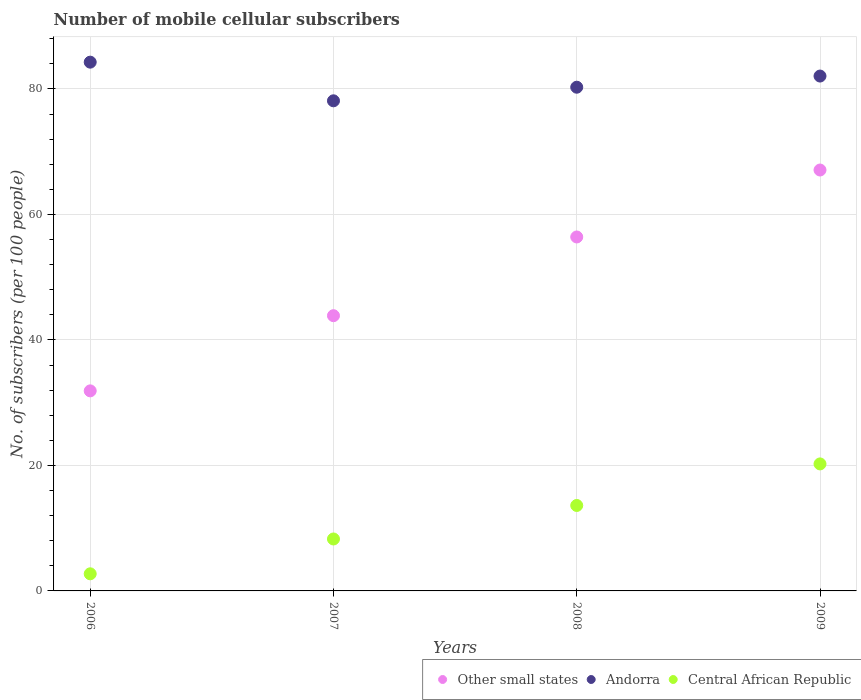How many different coloured dotlines are there?
Make the answer very short. 3. Is the number of dotlines equal to the number of legend labels?
Provide a short and direct response. Yes. What is the number of mobile cellular subscribers in Andorra in 2009?
Provide a short and direct response. 82.06. Across all years, what is the maximum number of mobile cellular subscribers in Central African Republic?
Give a very brief answer. 20.24. Across all years, what is the minimum number of mobile cellular subscribers in Other small states?
Give a very brief answer. 31.89. In which year was the number of mobile cellular subscribers in Central African Republic maximum?
Your answer should be compact. 2009. In which year was the number of mobile cellular subscribers in Andorra minimum?
Your answer should be compact. 2007. What is the total number of mobile cellular subscribers in Central African Republic in the graph?
Your answer should be compact. 44.87. What is the difference between the number of mobile cellular subscribers in Central African Republic in 2006 and that in 2008?
Your response must be concise. -10.89. What is the difference between the number of mobile cellular subscribers in Other small states in 2008 and the number of mobile cellular subscribers in Central African Republic in 2009?
Your response must be concise. 36.17. What is the average number of mobile cellular subscribers in Other small states per year?
Your answer should be compact. 49.81. In the year 2007, what is the difference between the number of mobile cellular subscribers in Andorra and number of mobile cellular subscribers in Other small states?
Provide a short and direct response. 34.25. What is the ratio of the number of mobile cellular subscribers in Central African Republic in 2006 to that in 2009?
Give a very brief answer. 0.13. Is the number of mobile cellular subscribers in Other small states in 2006 less than that in 2007?
Provide a succinct answer. Yes. What is the difference between the highest and the second highest number of mobile cellular subscribers in Central African Republic?
Keep it short and to the point. 6.62. What is the difference between the highest and the lowest number of mobile cellular subscribers in Andorra?
Provide a short and direct response. 6.16. In how many years, is the number of mobile cellular subscribers in Central African Republic greater than the average number of mobile cellular subscribers in Central African Republic taken over all years?
Provide a succinct answer. 2. Is it the case that in every year, the sum of the number of mobile cellular subscribers in Andorra and number of mobile cellular subscribers in Other small states  is greater than the number of mobile cellular subscribers in Central African Republic?
Give a very brief answer. Yes. How many dotlines are there?
Keep it short and to the point. 3. How many years are there in the graph?
Keep it short and to the point. 4. Are the values on the major ticks of Y-axis written in scientific E-notation?
Offer a terse response. No. Does the graph contain any zero values?
Ensure brevity in your answer.  No. Does the graph contain grids?
Keep it short and to the point. Yes. Where does the legend appear in the graph?
Make the answer very short. Bottom right. How many legend labels are there?
Make the answer very short. 3. How are the legend labels stacked?
Your response must be concise. Horizontal. What is the title of the graph?
Make the answer very short. Number of mobile cellular subscribers. What is the label or title of the Y-axis?
Provide a short and direct response. No. of subscribers (per 100 people). What is the No. of subscribers (per 100 people) in Other small states in 2006?
Ensure brevity in your answer.  31.89. What is the No. of subscribers (per 100 people) in Andorra in 2006?
Your response must be concise. 84.28. What is the No. of subscribers (per 100 people) in Central African Republic in 2006?
Ensure brevity in your answer.  2.73. What is the No. of subscribers (per 100 people) in Other small states in 2007?
Your answer should be very brief. 43.87. What is the No. of subscribers (per 100 people) in Andorra in 2007?
Offer a very short reply. 78.12. What is the No. of subscribers (per 100 people) in Central African Republic in 2007?
Provide a succinct answer. 8.28. What is the No. of subscribers (per 100 people) of Other small states in 2008?
Ensure brevity in your answer.  56.41. What is the No. of subscribers (per 100 people) in Andorra in 2008?
Provide a succinct answer. 80.28. What is the No. of subscribers (per 100 people) of Central African Republic in 2008?
Your response must be concise. 13.62. What is the No. of subscribers (per 100 people) in Other small states in 2009?
Ensure brevity in your answer.  67.09. What is the No. of subscribers (per 100 people) in Andorra in 2009?
Provide a succinct answer. 82.06. What is the No. of subscribers (per 100 people) of Central African Republic in 2009?
Your response must be concise. 20.24. Across all years, what is the maximum No. of subscribers (per 100 people) in Other small states?
Make the answer very short. 67.09. Across all years, what is the maximum No. of subscribers (per 100 people) of Andorra?
Provide a short and direct response. 84.28. Across all years, what is the maximum No. of subscribers (per 100 people) of Central African Republic?
Your answer should be very brief. 20.24. Across all years, what is the minimum No. of subscribers (per 100 people) in Other small states?
Offer a terse response. 31.89. Across all years, what is the minimum No. of subscribers (per 100 people) of Andorra?
Make the answer very short. 78.12. Across all years, what is the minimum No. of subscribers (per 100 people) of Central African Republic?
Provide a succinct answer. 2.73. What is the total No. of subscribers (per 100 people) of Other small states in the graph?
Make the answer very short. 199.26. What is the total No. of subscribers (per 100 people) in Andorra in the graph?
Offer a very short reply. 324.74. What is the total No. of subscribers (per 100 people) of Central African Republic in the graph?
Give a very brief answer. 44.87. What is the difference between the No. of subscribers (per 100 people) in Other small states in 2006 and that in 2007?
Provide a short and direct response. -11.98. What is the difference between the No. of subscribers (per 100 people) in Andorra in 2006 and that in 2007?
Your answer should be compact. 6.16. What is the difference between the No. of subscribers (per 100 people) in Central African Republic in 2006 and that in 2007?
Provide a succinct answer. -5.55. What is the difference between the No. of subscribers (per 100 people) in Other small states in 2006 and that in 2008?
Provide a short and direct response. -24.53. What is the difference between the No. of subscribers (per 100 people) in Andorra in 2006 and that in 2008?
Your response must be concise. 3.99. What is the difference between the No. of subscribers (per 100 people) of Central African Republic in 2006 and that in 2008?
Your answer should be very brief. -10.89. What is the difference between the No. of subscribers (per 100 people) of Other small states in 2006 and that in 2009?
Your answer should be compact. -35.2. What is the difference between the No. of subscribers (per 100 people) of Andorra in 2006 and that in 2009?
Provide a short and direct response. 2.22. What is the difference between the No. of subscribers (per 100 people) in Central African Republic in 2006 and that in 2009?
Your answer should be very brief. -17.52. What is the difference between the No. of subscribers (per 100 people) in Other small states in 2007 and that in 2008?
Make the answer very short. -12.55. What is the difference between the No. of subscribers (per 100 people) in Andorra in 2007 and that in 2008?
Keep it short and to the point. -2.17. What is the difference between the No. of subscribers (per 100 people) in Central African Republic in 2007 and that in 2008?
Give a very brief answer. -5.34. What is the difference between the No. of subscribers (per 100 people) of Other small states in 2007 and that in 2009?
Provide a short and direct response. -23.22. What is the difference between the No. of subscribers (per 100 people) of Andorra in 2007 and that in 2009?
Offer a very short reply. -3.94. What is the difference between the No. of subscribers (per 100 people) of Central African Republic in 2007 and that in 2009?
Provide a succinct answer. -11.96. What is the difference between the No. of subscribers (per 100 people) of Other small states in 2008 and that in 2009?
Your response must be concise. -10.67. What is the difference between the No. of subscribers (per 100 people) of Andorra in 2008 and that in 2009?
Ensure brevity in your answer.  -1.78. What is the difference between the No. of subscribers (per 100 people) of Central African Republic in 2008 and that in 2009?
Your answer should be very brief. -6.62. What is the difference between the No. of subscribers (per 100 people) in Other small states in 2006 and the No. of subscribers (per 100 people) in Andorra in 2007?
Give a very brief answer. -46.23. What is the difference between the No. of subscribers (per 100 people) in Other small states in 2006 and the No. of subscribers (per 100 people) in Central African Republic in 2007?
Offer a terse response. 23.61. What is the difference between the No. of subscribers (per 100 people) of Andorra in 2006 and the No. of subscribers (per 100 people) of Central African Republic in 2007?
Offer a terse response. 76. What is the difference between the No. of subscribers (per 100 people) of Other small states in 2006 and the No. of subscribers (per 100 people) of Andorra in 2008?
Give a very brief answer. -48.4. What is the difference between the No. of subscribers (per 100 people) of Other small states in 2006 and the No. of subscribers (per 100 people) of Central African Republic in 2008?
Provide a short and direct response. 18.27. What is the difference between the No. of subscribers (per 100 people) in Andorra in 2006 and the No. of subscribers (per 100 people) in Central African Republic in 2008?
Keep it short and to the point. 70.66. What is the difference between the No. of subscribers (per 100 people) of Other small states in 2006 and the No. of subscribers (per 100 people) of Andorra in 2009?
Your answer should be very brief. -50.18. What is the difference between the No. of subscribers (per 100 people) in Other small states in 2006 and the No. of subscribers (per 100 people) in Central African Republic in 2009?
Provide a short and direct response. 11.64. What is the difference between the No. of subscribers (per 100 people) of Andorra in 2006 and the No. of subscribers (per 100 people) of Central African Republic in 2009?
Offer a terse response. 64.03. What is the difference between the No. of subscribers (per 100 people) of Other small states in 2007 and the No. of subscribers (per 100 people) of Andorra in 2008?
Give a very brief answer. -36.42. What is the difference between the No. of subscribers (per 100 people) in Other small states in 2007 and the No. of subscribers (per 100 people) in Central African Republic in 2008?
Keep it short and to the point. 30.25. What is the difference between the No. of subscribers (per 100 people) of Andorra in 2007 and the No. of subscribers (per 100 people) of Central African Republic in 2008?
Your answer should be very brief. 64.5. What is the difference between the No. of subscribers (per 100 people) of Other small states in 2007 and the No. of subscribers (per 100 people) of Andorra in 2009?
Provide a short and direct response. -38.19. What is the difference between the No. of subscribers (per 100 people) in Other small states in 2007 and the No. of subscribers (per 100 people) in Central African Republic in 2009?
Keep it short and to the point. 23.62. What is the difference between the No. of subscribers (per 100 people) of Andorra in 2007 and the No. of subscribers (per 100 people) of Central African Republic in 2009?
Provide a succinct answer. 57.87. What is the difference between the No. of subscribers (per 100 people) of Other small states in 2008 and the No. of subscribers (per 100 people) of Andorra in 2009?
Your answer should be compact. -25.65. What is the difference between the No. of subscribers (per 100 people) of Other small states in 2008 and the No. of subscribers (per 100 people) of Central African Republic in 2009?
Your answer should be very brief. 36.17. What is the difference between the No. of subscribers (per 100 people) of Andorra in 2008 and the No. of subscribers (per 100 people) of Central African Republic in 2009?
Make the answer very short. 60.04. What is the average No. of subscribers (per 100 people) in Other small states per year?
Offer a terse response. 49.81. What is the average No. of subscribers (per 100 people) of Andorra per year?
Your answer should be very brief. 81.19. What is the average No. of subscribers (per 100 people) in Central African Republic per year?
Give a very brief answer. 11.22. In the year 2006, what is the difference between the No. of subscribers (per 100 people) of Other small states and No. of subscribers (per 100 people) of Andorra?
Provide a short and direct response. -52.39. In the year 2006, what is the difference between the No. of subscribers (per 100 people) of Other small states and No. of subscribers (per 100 people) of Central African Republic?
Your answer should be compact. 29.16. In the year 2006, what is the difference between the No. of subscribers (per 100 people) in Andorra and No. of subscribers (per 100 people) in Central African Republic?
Provide a short and direct response. 81.55. In the year 2007, what is the difference between the No. of subscribers (per 100 people) of Other small states and No. of subscribers (per 100 people) of Andorra?
Your answer should be compact. -34.25. In the year 2007, what is the difference between the No. of subscribers (per 100 people) of Other small states and No. of subscribers (per 100 people) of Central African Republic?
Keep it short and to the point. 35.59. In the year 2007, what is the difference between the No. of subscribers (per 100 people) in Andorra and No. of subscribers (per 100 people) in Central African Republic?
Provide a short and direct response. 69.84. In the year 2008, what is the difference between the No. of subscribers (per 100 people) in Other small states and No. of subscribers (per 100 people) in Andorra?
Offer a terse response. -23.87. In the year 2008, what is the difference between the No. of subscribers (per 100 people) of Other small states and No. of subscribers (per 100 people) of Central African Republic?
Offer a terse response. 42.8. In the year 2008, what is the difference between the No. of subscribers (per 100 people) of Andorra and No. of subscribers (per 100 people) of Central African Republic?
Your answer should be compact. 66.66. In the year 2009, what is the difference between the No. of subscribers (per 100 people) in Other small states and No. of subscribers (per 100 people) in Andorra?
Give a very brief answer. -14.98. In the year 2009, what is the difference between the No. of subscribers (per 100 people) in Other small states and No. of subscribers (per 100 people) in Central African Republic?
Keep it short and to the point. 46.84. In the year 2009, what is the difference between the No. of subscribers (per 100 people) of Andorra and No. of subscribers (per 100 people) of Central African Republic?
Offer a very short reply. 61.82. What is the ratio of the No. of subscribers (per 100 people) of Other small states in 2006 to that in 2007?
Keep it short and to the point. 0.73. What is the ratio of the No. of subscribers (per 100 people) in Andorra in 2006 to that in 2007?
Provide a succinct answer. 1.08. What is the ratio of the No. of subscribers (per 100 people) in Central African Republic in 2006 to that in 2007?
Your answer should be compact. 0.33. What is the ratio of the No. of subscribers (per 100 people) in Other small states in 2006 to that in 2008?
Your response must be concise. 0.57. What is the ratio of the No. of subscribers (per 100 people) in Andorra in 2006 to that in 2008?
Provide a succinct answer. 1.05. What is the ratio of the No. of subscribers (per 100 people) of Central African Republic in 2006 to that in 2008?
Ensure brevity in your answer.  0.2. What is the ratio of the No. of subscribers (per 100 people) in Other small states in 2006 to that in 2009?
Provide a short and direct response. 0.48. What is the ratio of the No. of subscribers (per 100 people) of Andorra in 2006 to that in 2009?
Your answer should be very brief. 1.03. What is the ratio of the No. of subscribers (per 100 people) of Central African Republic in 2006 to that in 2009?
Provide a succinct answer. 0.13. What is the ratio of the No. of subscribers (per 100 people) in Other small states in 2007 to that in 2008?
Provide a succinct answer. 0.78. What is the ratio of the No. of subscribers (per 100 people) of Andorra in 2007 to that in 2008?
Your response must be concise. 0.97. What is the ratio of the No. of subscribers (per 100 people) of Central African Republic in 2007 to that in 2008?
Make the answer very short. 0.61. What is the ratio of the No. of subscribers (per 100 people) in Other small states in 2007 to that in 2009?
Your answer should be very brief. 0.65. What is the ratio of the No. of subscribers (per 100 people) in Andorra in 2007 to that in 2009?
Make the answer very short. 0.95. What is the ratio of the No. of subscribers (per 100 people) in Central African Republic in 2007 to that in 2009?
Give a very brief answer. 0.41. What is the ratio of the No. of subscribers (per 100 people) in Other small states in 2008 to that in 2009?
Your answer should be compact. 0.84. What is the ratio of the No. of subscribers (per 100 people) in Andorra in 2008 to that in 2009?
Offer a terse response. 0.98. What is the ratio of the No. of subscribers (per 100 people) of Central African Republic in 2008 to that in 2009?
Your answer should be compact. 0.67. What is the difference between the highest and the second highest No. of subscribers (per 100 people) in Other small states?
Your response must be concise. 10.67. What is the difference between the highest and the second highest No. of subscribers (per 100 people) of Andorra?
Offer a terse response. 2.22. What is the difference between the highest and the second highest No. of subscribers (per 100 people) of Central African Republic?
Your answer should be very brief. 6.62. What is the difference between the highest and the lowest No. of subscribers (per 100 people) of Other small states?
Offer a terse response. 35.2. What is the difference between the highest and the lowest No. of subscribers (per 100 people) in Andorra?
Provide a succinct answer. 6.16. What is the difference between the highest and the lowest No. of subscribers (per 100 people) in Central African Republic?
Keep it short and to the point. 17.52. 